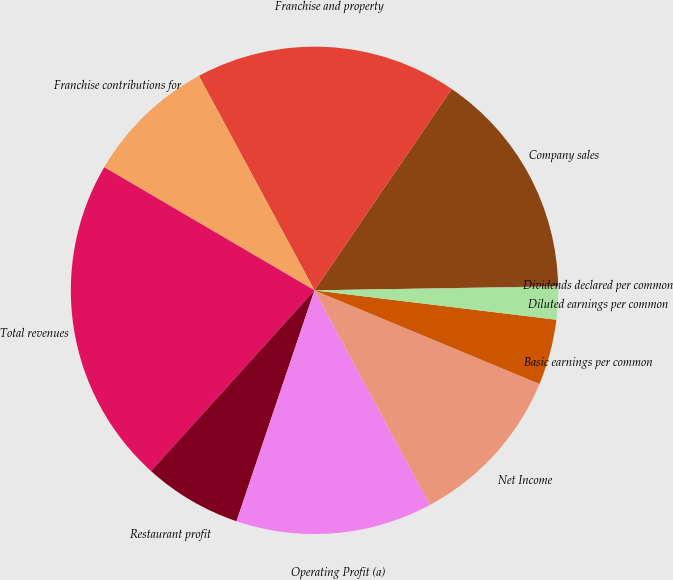Convert chart. <chart><loc_0><loc_0><loc_500><loc_500><pie_chart><fcel>Company sales<fcel>Franchise and property<fcel>Franchise contributions for<fcel>Total revenues<fcel>Restaurant profit<fcel>Operating Profit (a)<fcel>Net Income<fcel>Basic earnings per common<fcel>Diluted earnings per common<fcel>Dividends declared per common<nl><fcel>15.21%<fcel>17.39%<fcel>8.7%<fcel>21.73%<fcel>6.52%<fcel>13.04%<fcel>10.87%<fcel>4.35%<fcel>2.18%<fcel>0.01%<nl></chart> 